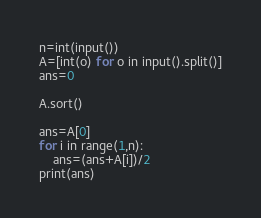Convert code to text. <code><loc_0><loc_0><loc_500><loc_500><_Python_>n=int(input())
A=[int(o) for o in input().split()]
ans=0

A.sort()

ans=A[0]
for i in range(1,n):
    ans=(ans+A[i])/2
print(ans)</code> 